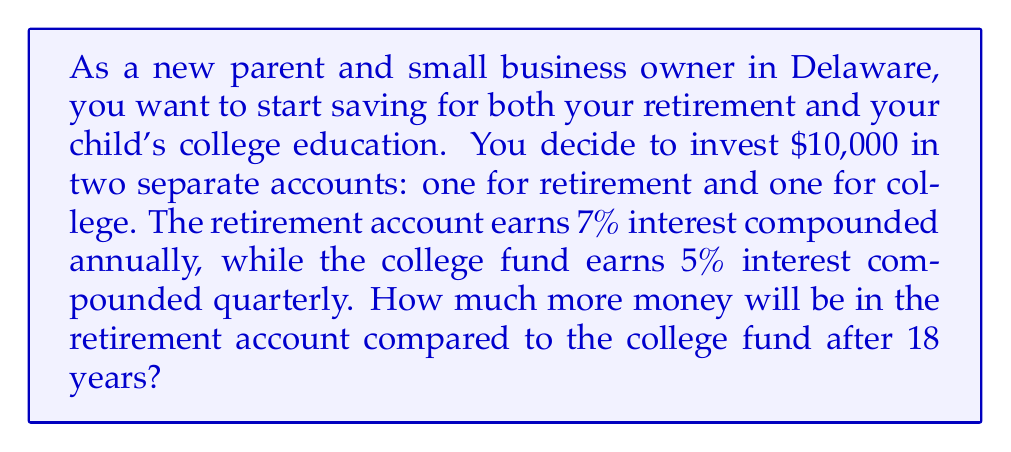Can you answer this question? Let's approach this problem step-by-step:

1. For the retirement account:
   - Principal (P) = $5,000 (half of the $10,000)
   - Annual interest rate (r) = 7% = 0.07
   - Time (t) = 18 years
   - Compounding frequency (n) = 1 (annually)

   Using the compound interest formula: $A = P(1 + \frac{r}{n})^{nt}$

   $A_{\text{retirement}} = 5000(1 + \frac{0.07}{1})^{1 \cdot 18}$
   $= 5000(1.07)^{18}$
   $= 5000 \cdot 3.3772256$
   $= 16,886.13$

2. For the college fund:
   - Principal (P) = $5,000 (half of the $10,000)
   - Annual interest rate (r) = 5% = 0.05
   - Time (t) = 18 years
   - Compounding frequency (n) = 4 (quarterly)

   Using the same formula:

   $A_{\text{college}} = 5000(1 + \frac{0.05}{4})^{4 \cdot 18}$
   $= 5000(1.0125)^{72}$
   $= 5000 \cdot 2.4466583$
   $= 12,233.29$

3. To find the difference:
   $\text{Difference} = A_{\text{retirement}} - A_{\text{college}}$
   $= 16,886.13 - 12,233.29$
   $= 4,652.84$
Answer: $4,652.84 